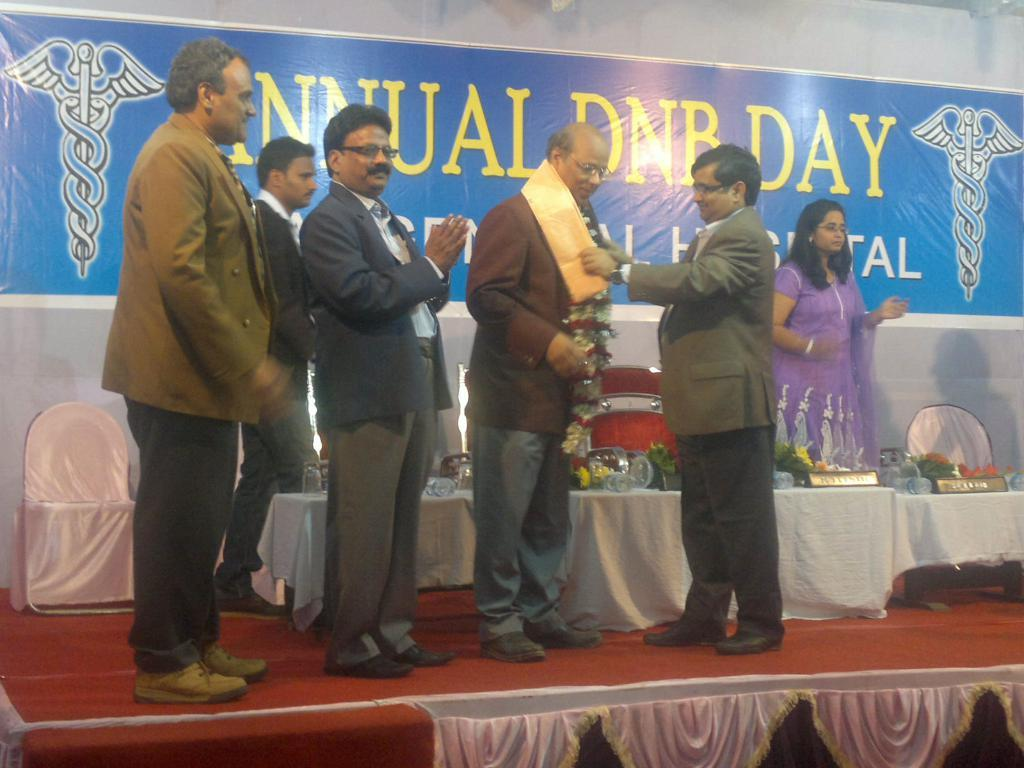How many people are present in the image? There are six people standing in the image. What can be seen in the image besides the people? There are chairs and objects on the tables in the image. What is attached to the wall in the background of the image? There is a banner attached to the wall in the background of the image. What type of ball is being used by the group in the image? There is no ball present in the image; it features six people standing near chairs and tables. 